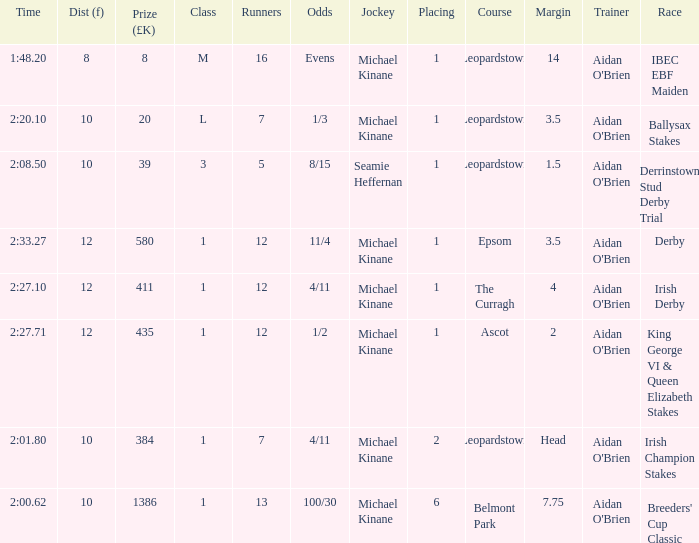Name the highest Dist (f) with Odds of 11/4 and a Placing larger than 1? None. 